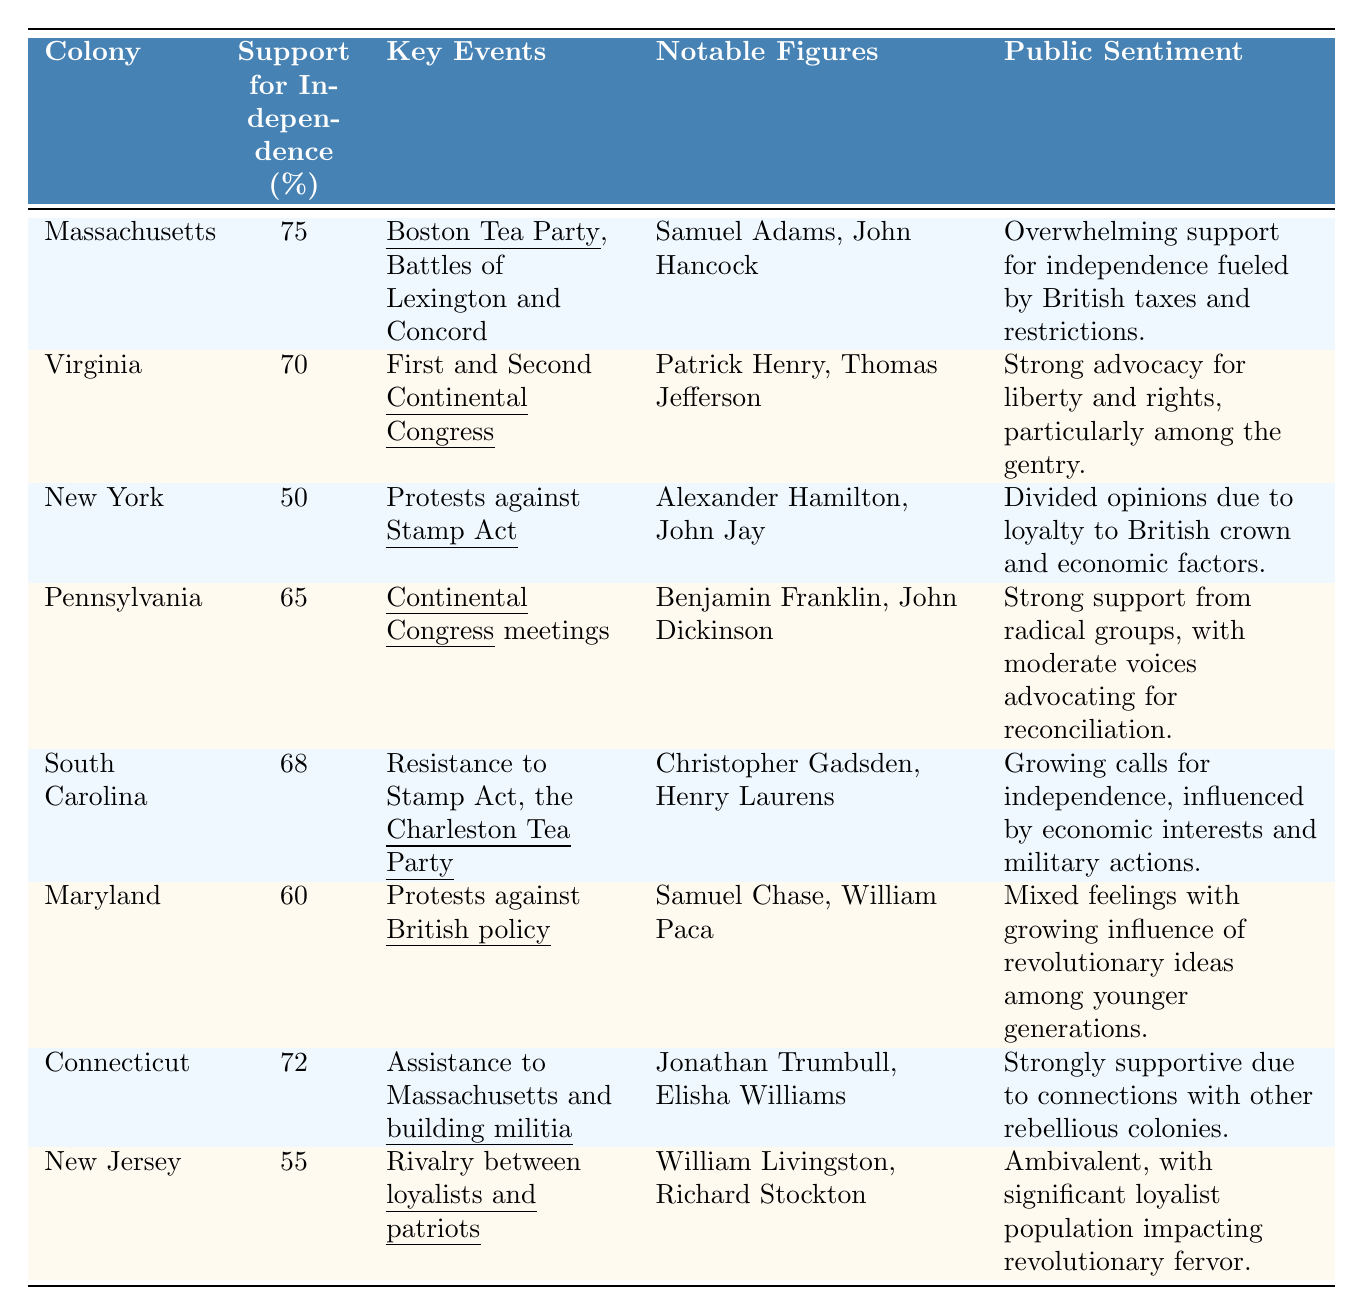What colony had the highest support for independence? By examining the support for independence percentages in the table, Massachusetts has the highest support at 75%.
Answer: Massachusetts Which notable figure was associated with the resistance to the Stamp Act? The table shows that both New York and South Carolina had key events related to the Stamp Act. However, South Carolina mentions "Resistance to Stamp Act" prominently, but New York is explicitly linked to protests against it. So either Alexander Hamilton or John Jay (for New York) and Christopher Gadsden or Henry Laurens (for South Carolina) could be considered.
Answer: Alexander Hamilton, John Jay, Christopher Gadsden, or Henry Laurens What is the average support for independence across the colonies listed? The support percentages are 75, 70, 50, 65, 68, 60, 72, 55. Summing these gives 75 + 70 + 50 + 65 + 68 + 60 + 72 + 55 =  75 + 70 + 50 + 65 + 68 + 60 + 72 + 55 =  626. There are 8 colonies, so the average is 626 / 8 = 78.25, rounded to one decimal place.
Answer: 78.3 Did Connecticut have a lower percentage of support compared to New Jersey? Connecticut's support for independence is 72%, while New Jersey's is 55%, making Connecticut's support higher than New Jersey.
Answer: No What can be said about Massachusetts' public sentiment regarding independence compared to Virginia's? Massachusetts has an overwhelming support for independence fueled by British actions, while Virginia exhibits strong advocacy focused on liberty, particularly from the gentry class. Both exhibit strong sentiments but differ in their focus and intensity.
Answer: Massachusetts felt more overwhelmingly supportive Which colonies experienced significant division in public opinion regarding independence? According to the table, New York shows divided opinions mainly due to loyalty to the British crown and economic factors, while New Jersey's population is described as ambivalent with a significant loyalist presence causing impact. Both colonies experienced notable divisions in their public sentiments.
Answer: New York and New Jersey What percentage support for independence does South Carolina have compared to Maryland? South Carolina has 68% support for independence, and Maryland has 60%. So, South Carolina has higher support by 8%.
Answer: South Carolina has higher support by 8% What is the public sentiment in Pennsylvania regarding independence? The table indicates that Pennsylvania has strong support from radical groups, with moderate voices still advocating for reconciliation, reflecting a mixture of support and caution among the populace.
Answer: Mixed feelings with strong radical support 